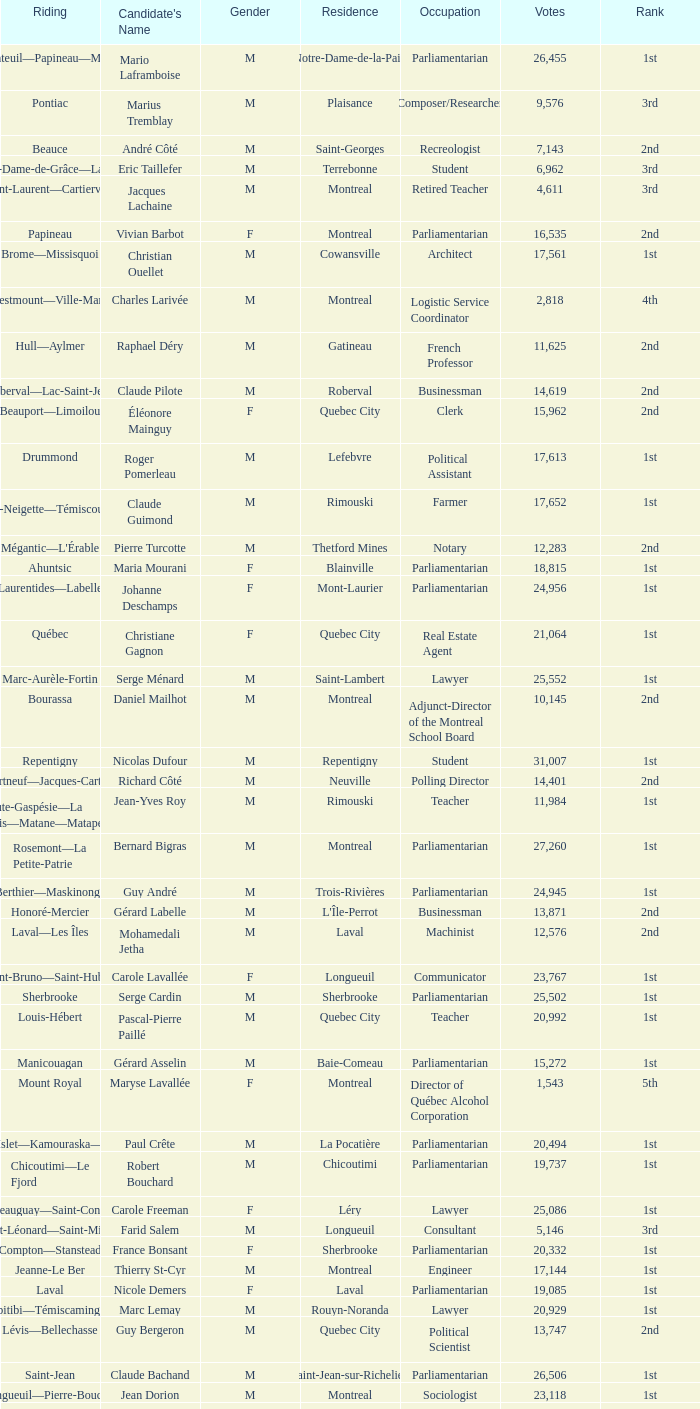What is the highest number of votes for the French Professor? 11625.0. 